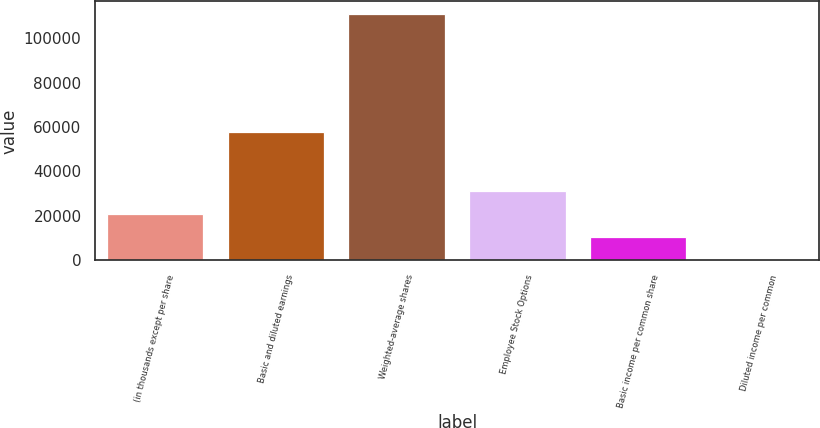Convert chart to OTSL. <chart><loc_0><loc_0><loc_500><loc_500><bar_chart><fcel>(in thousands except per share<fcel>Basic and diluted earnings<fcel>Weighted-average shares<fcel>Employee Stock Options<fcel>Basic income per common share<fcel>Diluted income per common<nl><fcel>20663.2<fcel>57809<fcel>111078<fcel>30994.6<fcel>10331.9<fcel>0.56<nl></chart> 